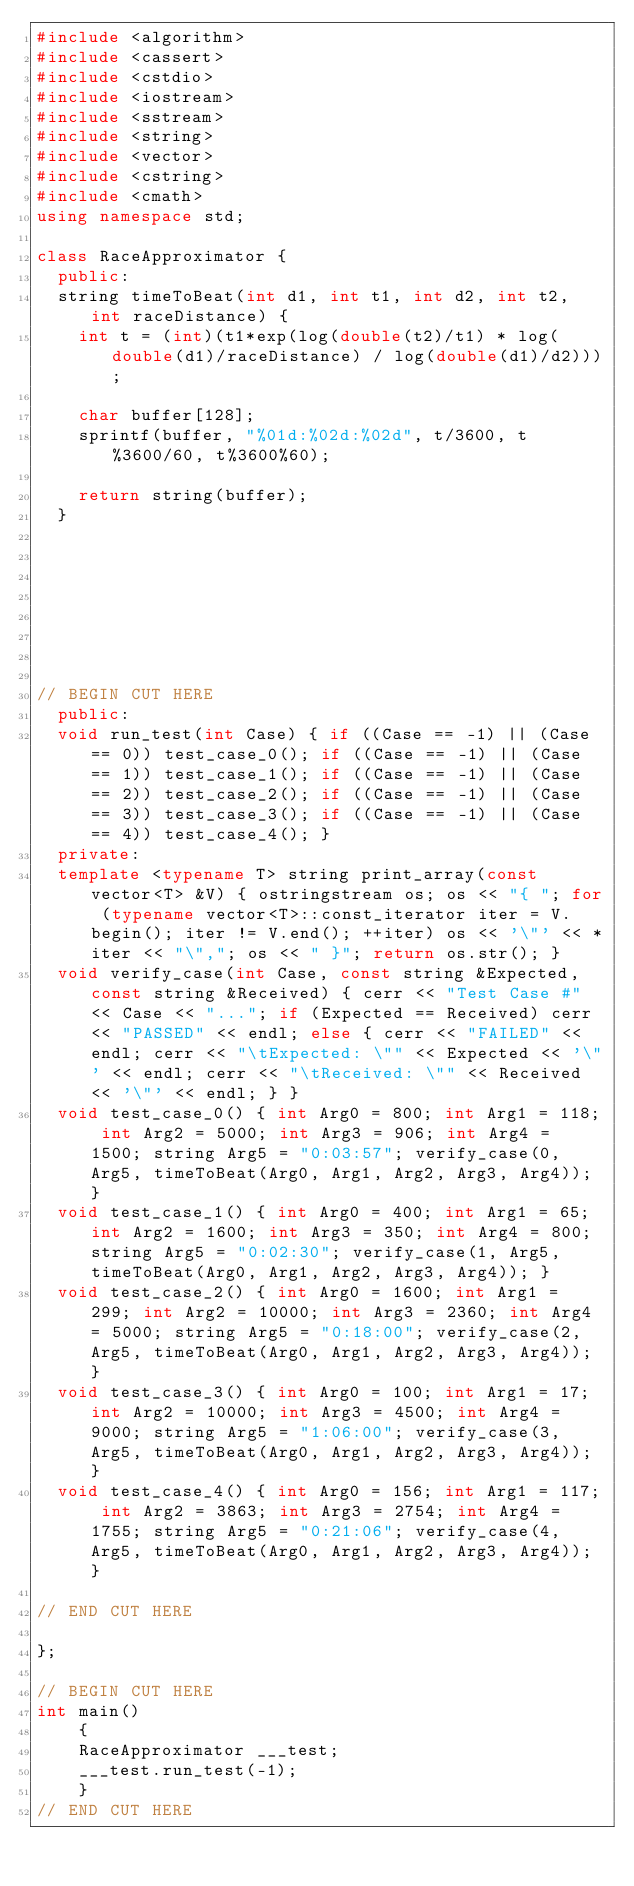<code> <loc_0><loc_0><loc_500><loc_500><_C++_>#include <algorithm>
#include <cassert>
#include <cstdio>
#include <iostream>
#include <sstream>
#include <string>
#include <vector>
#include <cstring>
#include <cmath>
using namespace std;

class RaceApproximator {
	public:
	string timeToBeat(int d1, int t1, int d2, int t2, int raceDistance) {
		int t = (int)(t1*exp(log(double(t2)/t1) * log(double(d1)/raceDistance) / log(double(d1)/d2)));

		char buffer[128];
		sprintf(buffer, "%01d:%02d:%02d", t/3600, t%3600/60, t%3600%60);

		return string(buffer);
	}








// BEGIN CUT HERE
	public:
	void run_test(int Case) { if ((Case == -1) || (Case == 0)) test_case_0(); if ((Case == -1) || (Case == 1)) test_case_1(); if ((Case == -1) || (Case == 2)) test_case_2(); if ((Case == -1) || (Case == 3)) test_case_3(); if ((Case == -1) || (Case == 4)) test_case_4(); }
	private:
	template <typename T> string print_array(const vector<T> &V) { ostringstream os; os << "{ "; for (typename vector<T>::const_iterator iter = V.begin(); iter != V.end(); ++iter) os << '\"' << *iter << "\","; os << " }"; return os.str(); }
	void verify_case(int Case, const string &Expected, const string &Received) { cerr << "Test Case #" << Case << "..."; if (Expected == Received) cerr << "PASSED" << endl; else { cerr << "FAILED" << endl; cerr << "\tExpected: \"" << Expected << '\"' << endl; cerr << "\tReceived: \"" << Received << '\"' << endl; } }
	void test_case_0() { int Arg0 = 800; int Arg1 = 118; int Arg2 = 5000; int Arg3 = 906; int Arg4 = 1500; string Arg5 = "0:03:57"; verify_case(0, Arg5, timeToBeat(Arg0, Arg1, Arg2, Arg3, Arg4)); }
	void test_case_1() { int Arg0 = 400; int Arg1 = 65; int Arg2 = 1600; int Arg3 = 350; int Arg4 = 800; string Arg5 = "0:02:30"; verify_case(1, Arg5, timeToBeat(Arg0, Arg1, Arg2, Arg3, Arg4)); }
	void test_case_2() { int Arg0 = 1600; int Arg1 = 299; int Arg2 = 10000; int Arg3 = 2360; int Arg4 = 5000; string Arg5 = "0:18:00"; verify_case(2, Arg5, timeToBeat(Arg0, Arg1, Arg2, Arg3, Arg4)); }
	void test_case_3() { int Arg0 = 100; int Arg1 = 17; int Arg2 = 10000; int Arg3 = 4500; int Arg4 = 9000; string Arg5 = "1:06:00"; verify_case(3, Arg5, timeToBeat(Arg0, Arg1, Arg2, Arg3, Arg4)); }
	void test_case_4() { int Arg0 = 156; int Arg1 = 117; int Arg2 = 3863; int Arg3 = 2754; int Arg4 = 1755; string Arg5 = "0:21:06"; verify_case(4, Arg5, timeToBeat(Arg0, Arg1, Arg2, Arg3, Arg4)); }

// END CUT HERE

};

// BEGIN CUT HERE
int main()
    {
    RaceApproximator ___test;
    ___test.run_test(-1);
    }
// END CUT HERE
</code> 